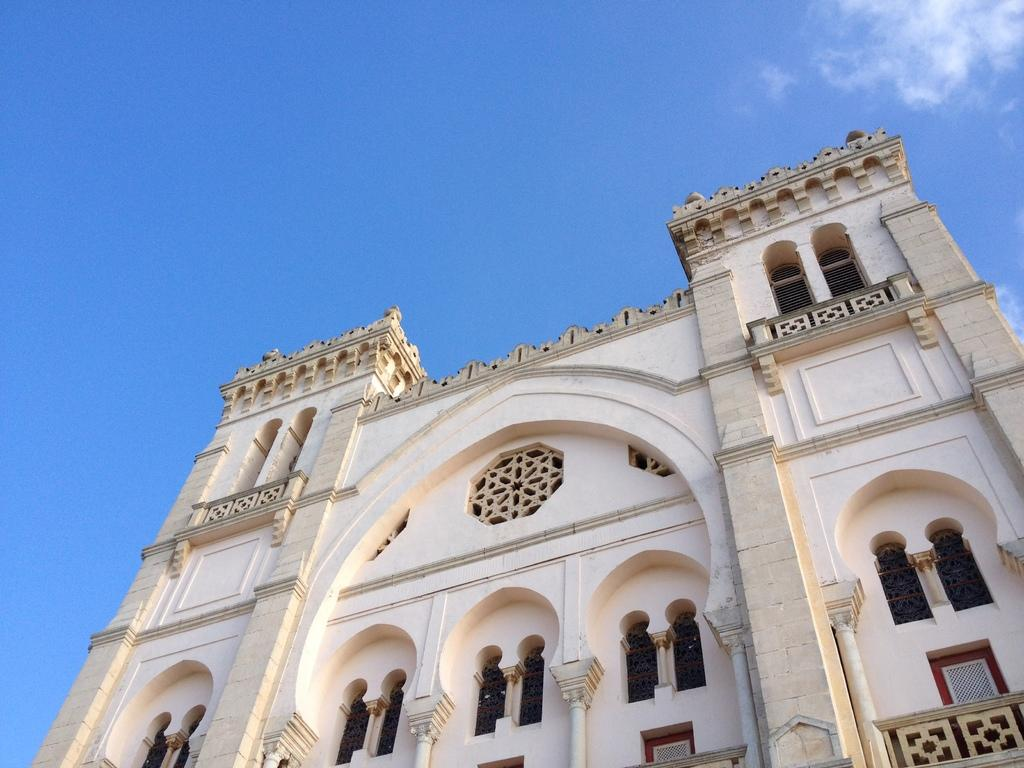What type of structure is present in the image? There is a building in the image. What can be seen in the background of the image? The sky is visible in the background of the image. What type of boat is visible in the image? There is no boat present in the image. What material is the building made of, specifically the steel components? The provided facts do not mention any specific materials used in the construction of the building, so we cannot determine if there are steel components. 